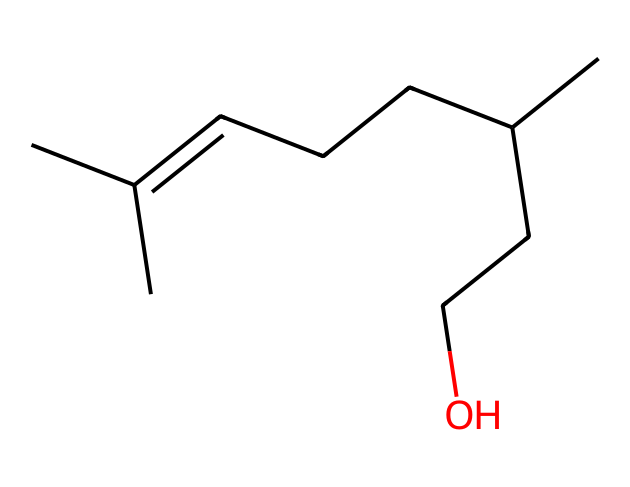How many carbon atoms are in citronellol? By analyzing the SMILES representation, we can count the carbon atoms represented by the letter "C". There are 10 carbon atoms in total.
Answer: 10 What type of compound is citronellol? Citronellol is classified as a terpene alcohol, which can be inferred from its structure that contains both a hydrocarbon chain and a hydroxyl (-OH) functional group.
Answer: terpene alcohol How many hydrogen atoms are present in citronellol? To determine the number of hydrogen atoms, we consider the structure of the compound where each carbon typically bonds with enough hydrogen to satisfy its tetravalency. Upon inspection, the total number of hydrogen atoms is 18.
Answer: 18 What functional group is present in citronellol? The presence of the -OH group in the structure indicates that it has an alcohol functional group, which is characteristic of alcohol compounds.
Answer: alcohol Which part of the molecule contributes to its fragrance? The long hydrocarbon chain and the specific arrangement of atoms (including the carbon-carbon double bond and the -OH group) are characteristic of compounds that have a pleasant fragrance. Therefore, the overall structure and particularly the presence of the -OH group contribute to its fragrant properties.
Answer: -OH group Is citronellol considered to be hydrophilic or hydrophobic? Considering the presence of the hydroxyl (-OH) group, which can form hydrogen bonds with water, we determine that citronellol exhibits hydrophilic properties due to its alcohol nature.
Answer: hydrophilic 